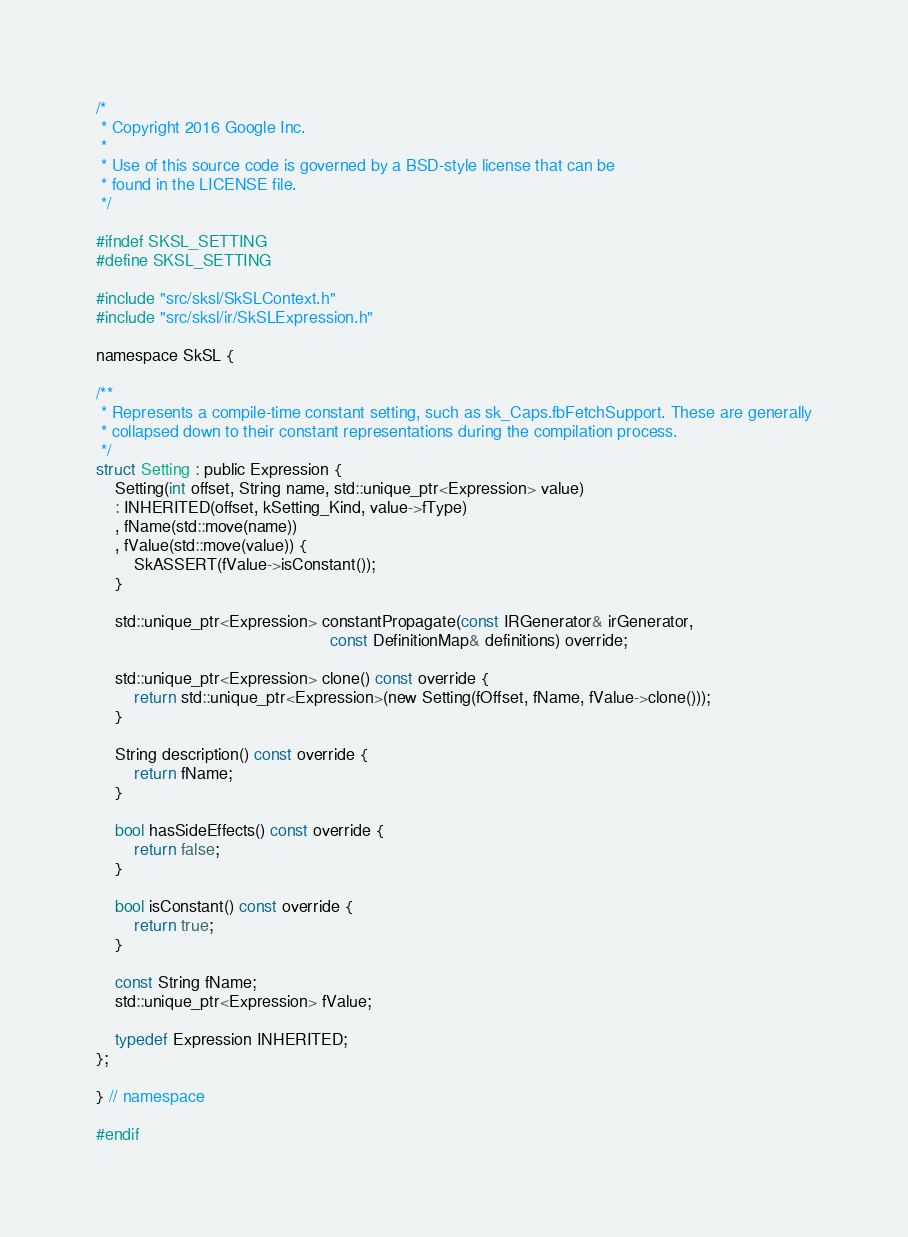<code> <loc_0><loc_0><loc_500><loc_500><_C_>/*
 * Copyright 2016 Google Inc.
 *
 * Use of this source code is governed by a BSD-style license that can be
 * found in the LICENSE file.
 */

#ifndef SKSL_SETTING
#define SKSL_SETTING

#include "src/sksl/SkSLContext.h"
#include "src/sksl/ir/SkSLExpression.h"

namespace SkSL {

/**
 * Represents a compile-time constant setting, such as sk_Caps.fbFetchSupport. These are generally
 * collapsed down to their constant representations during the compilation process.
 */
struct Setting : public Expression {
    Setting(int offset, String name, std::unique_ptr<Expression> value)
    : INHERITED(offset, kSetting_Kind, value->fType)
    , fName(std::move(name))
    , fValue(std::move(value)) {
        SkASSERT(fValue->isConstant());
    }

    std::unique_ptr<Expression> constantPropagate(const IRGenerator& irGenerator,
                                                  const DefinitionMap& definitions) override;

    std::unique_ptr<Expression> clone() const override {
        return std::unique_ptr<Expression>(new Setting(fOffset, fName, fValue->clone()));
    }

    String description() const override {
        return fName;
    }

    bool hasSideEffects() const override {
        return false;
    }

    bool isConstant() const override {
        return true;
    }

    const String fName;
    std::unique_ptr<Expression> fValue;

    typedef Expression INHERITED;
};

} // namespace

#endif
</code> 